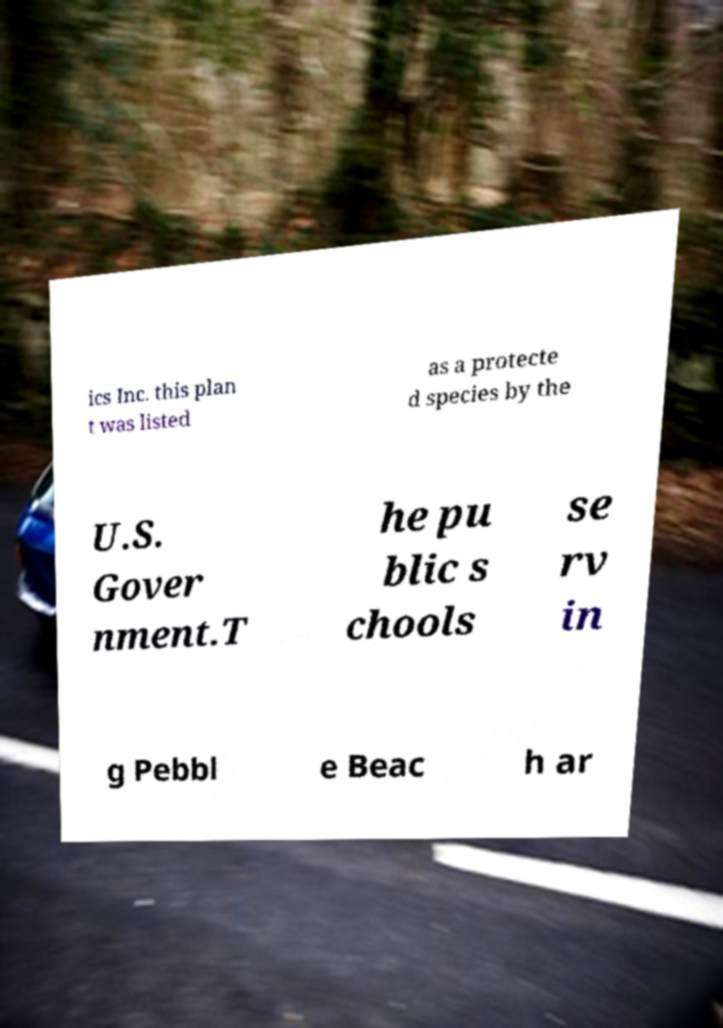Can you accurately transcribe the text from the provided image for me? ics Inc. this plan t was listed as a protecte d species by the U.S. Gover nment.T he pu blic s chools se rv in g Pebbl e Beac h ar 